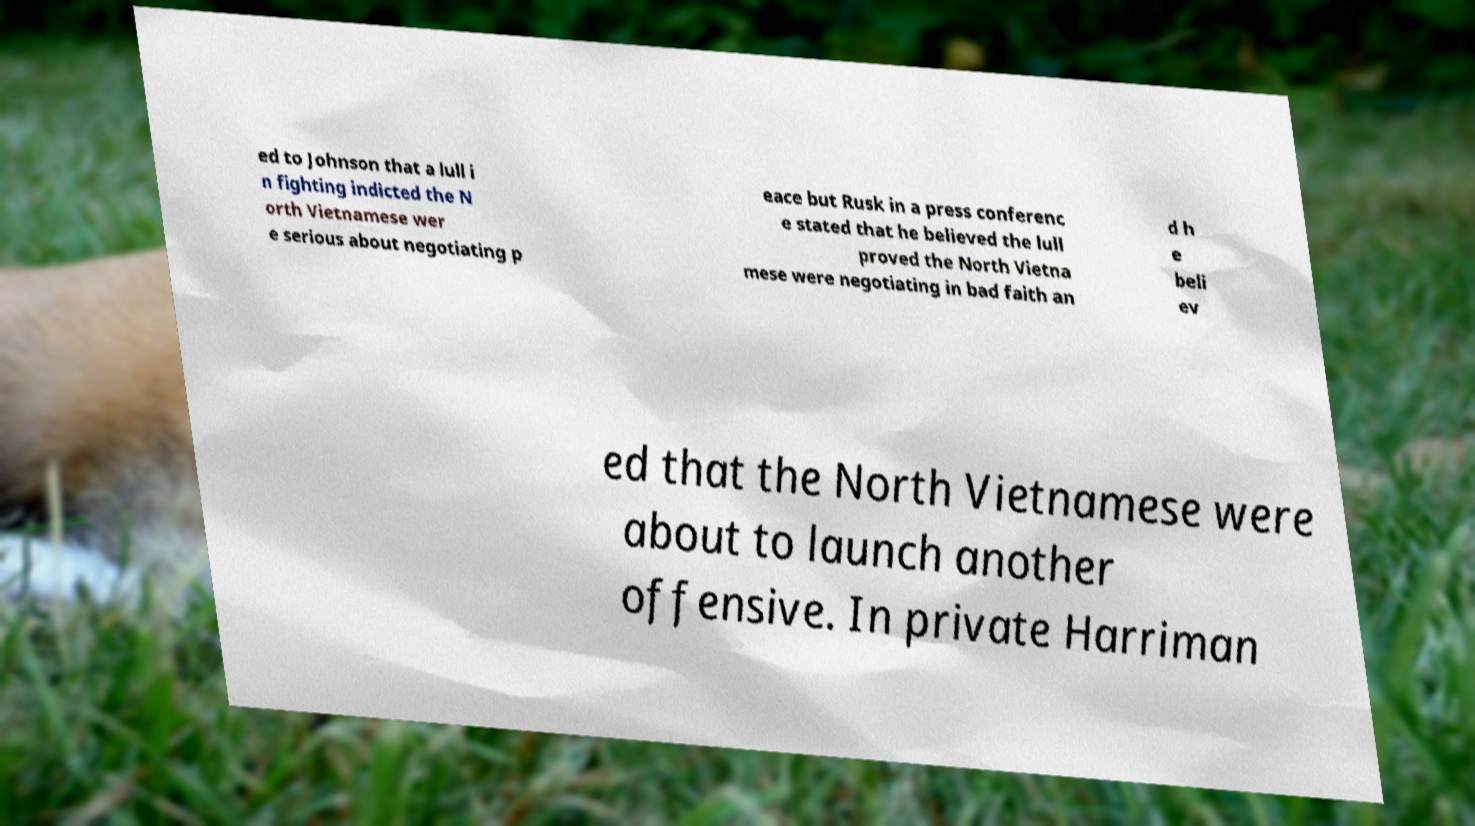Can you read and provide the text displayed in the image?This photo seems to have some interesting text. Can you extract and type it out for me? ed to Johnson that a lull i n fighting indicted the N orth Vietnamese wer e serious about negotiating p eace but Rusk in a press conferenc e stated that he believed the lull proved the North Vietna mese were negotiating in bad faith an d h e beli ev ed that the North Vietnamese were about to launch another offensive. In private Harriman 